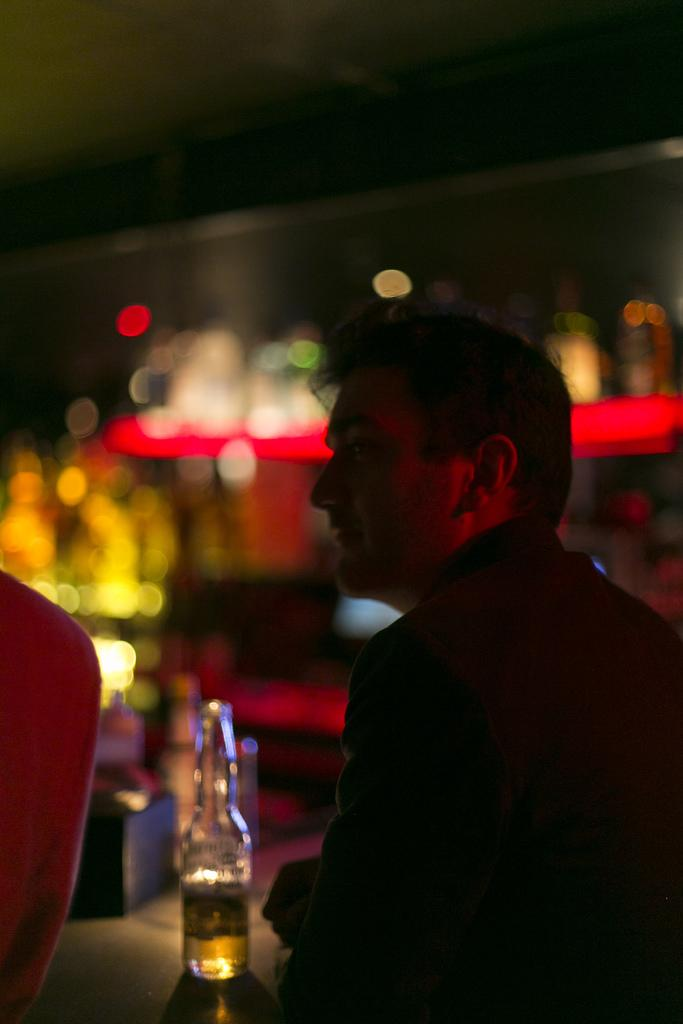What can be observed about the background of the image? The background of the picture is blurred. What object is present in the image that contains a liquid? There is a bottle in the image, and it contains a drink. Who is in the image? There is a man in the image. What is the man wearing? The man is wearing a black dress. On which side of the image is the man located? The man is on the right side of the image. What type of jam is being spread on the books in the image? There are no books or jam present in the image. Where is the nest located in the image? There is no nest present in the image. 